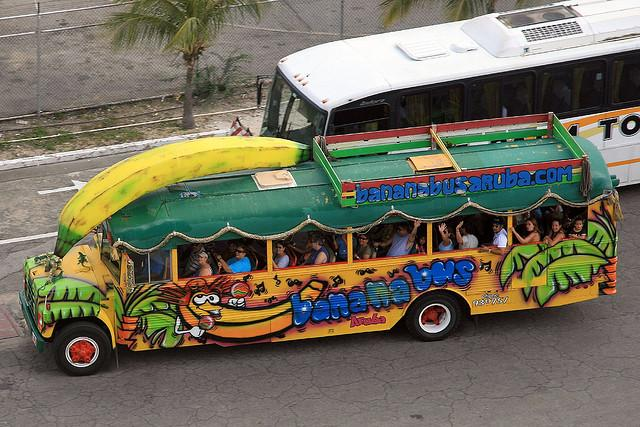Which one of these is a sister island to this location?

Choices:
A) jamaica
B) bonaire
C) barbados
D) cuba bonaire 